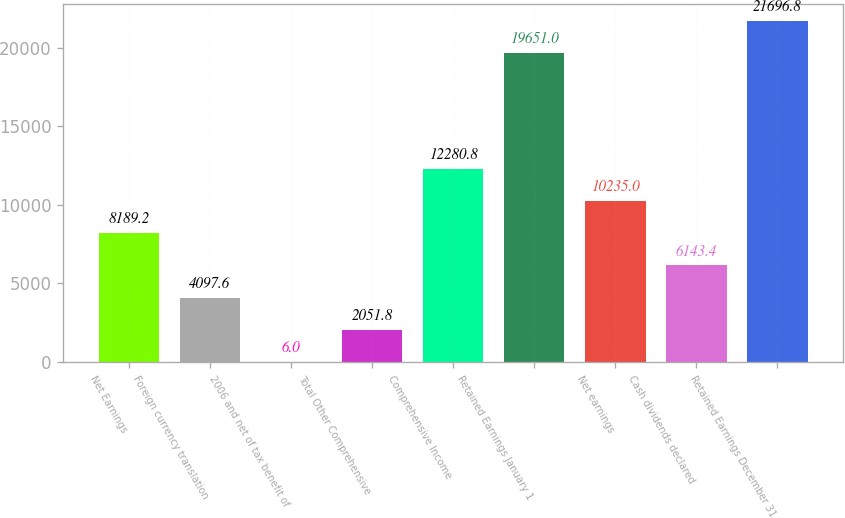Convert chart. <chart><loc_0><loc_0><loc_500><loc_500><bar_chart><fcel>Net Earnings<fcel>Foreign currency translation<fcel>2006 and net of tax benefit of<fcel>Total Other Comprehensive<fcel>Comprehensive Income<fcel>Retained Earnings January 1<fcel>Net earnings<fcel>Cash dividends declared<fcel>Retained Earnings December 31<nl><fcel>8189.2<fcel>4097.6<fcel>6<fcel>2051.8<fcel>12280.8<fcel>19651<fcel>10235<fcel>6143.4<fcel>21696.8<nl></chart> 